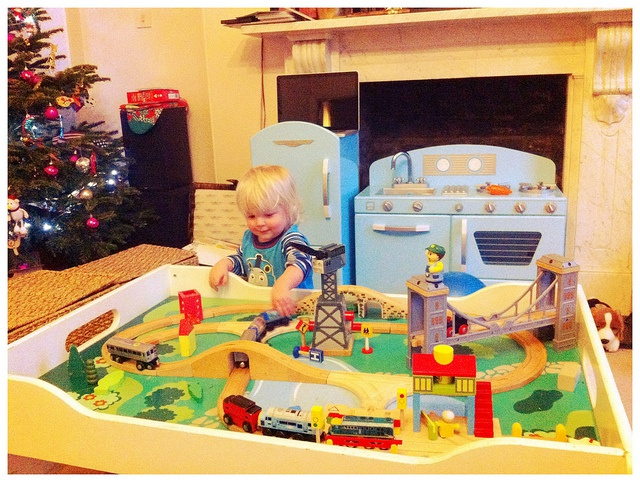Describe the objects in this image and their specific colors. I can see refrigerator in white, beige, lightgray, darkgray, and lightblue tones, people in white, tan, and salmon tones, oven in white, lightgray, darkgray, navy, and gray tones, train in white, red, black, maroon, and khaki tones, and tv in white, maroon, black, gold, and tan tones in this image. 